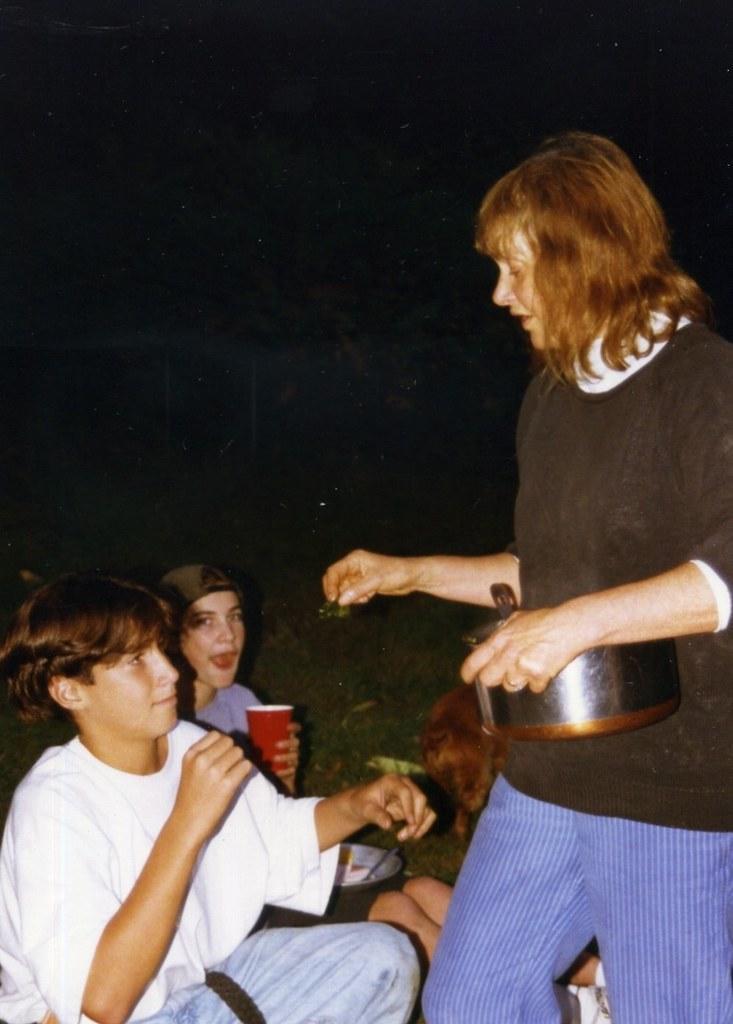Can you describe this image briefly? Here in this picture, on the right side we can see a woman standing over a place and is holding a bowl in her hand and in front of her we can see two children sitting on the ground and she is giving something to the child and one child is wearing a cap and holding a cup in his hand and we can see grass present on the ground. 